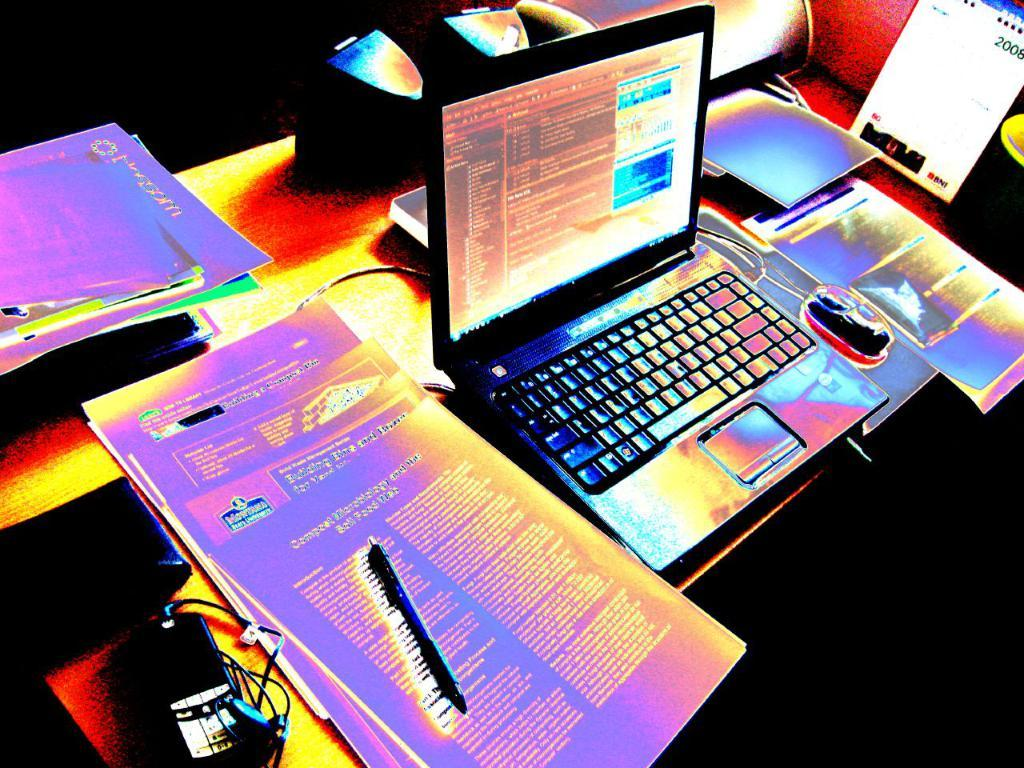<image>
Present a compact description of the photo's key features. A laptop is surrounded by papers and various computer accessories, while a calendar on the year 2008 sits in the background. 